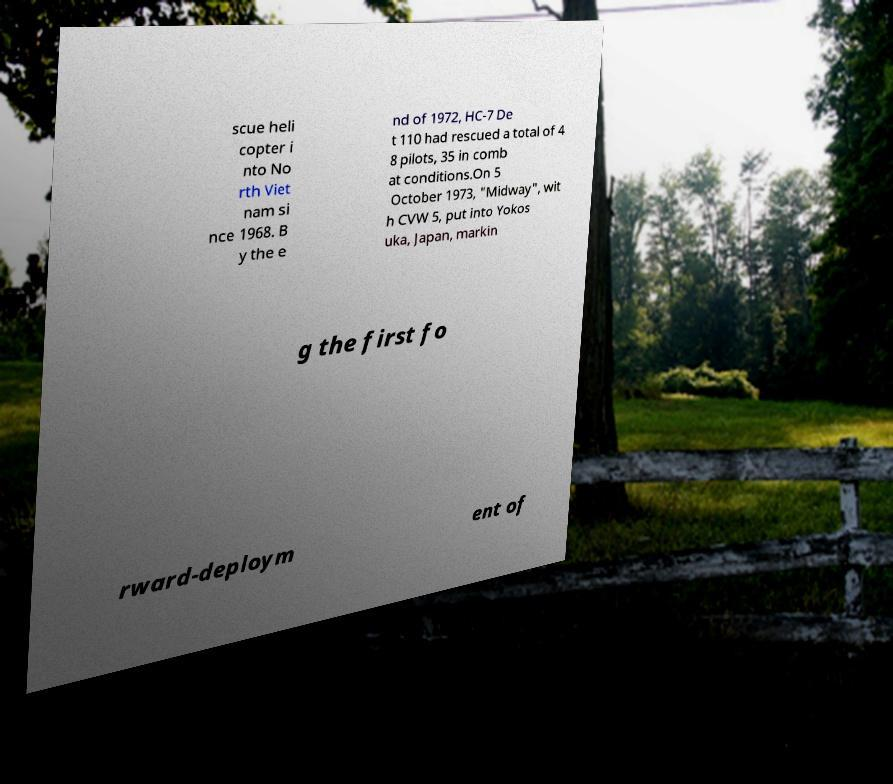For documentation purposes, I need the text within this image transcribed. Could you provide that? scue heli copter i nto No rth Viet nam si nce 1968. B y the e nd of 1972, HC-7 De t 110 had rescued a total of 4 8 pilots, 35 in comb at conditions.On 5 October 1973, "Midway", wit h CVW 5, put into Yokos uka, Japan, markin g the first fo rward-deploym ent of 